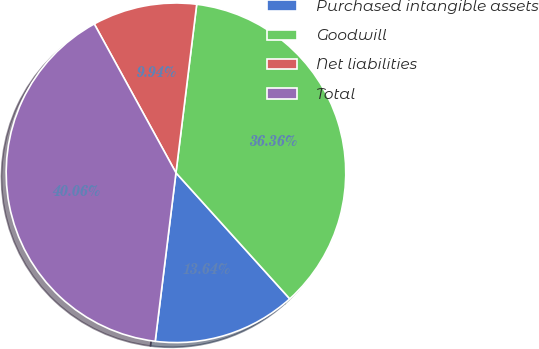Convert chart. <chart><loc_0><loc_0><loc_500><loc_500><pie_chart><fcel>Purchased intangible assets<fcel>Goodwill<fcel>Net liabilities<fcel>Total<nl><fcel>13.64%<fcel>36.36%<fcel>9.94%<fcel>40.06%<nl></chart> 